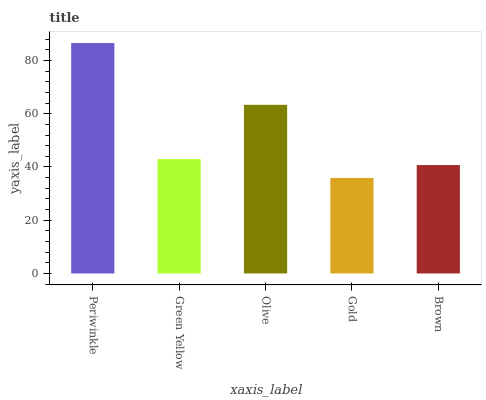Is Gold the minimum?
Answer yes or no. Yes. Is Periwinkle the maximum?
Answer yes or no. Yes. Is Green Yellow the minimum?
Answer yes or no. No. Is Green Yellow the maximum?
Answer yes or no. No. Is Periwinkle greater than Green Yellow?
Answer yes or no. Yes. Is Green Yellow less than Periwinkle?
Answer yes or no. Yes. Is Green Yellow greater than Periwinkle?
Answer yes or no. No. Is Periwinkle less than Green Yellow?
Answer yes or no. No. Is Green Yellow the high median?
Answer yes or no. Yes. Is Green Yellow the low median?
Answer yes or no. Yes. Is Gold the high median?
Answer yes or no. No. Is Periwinkle the low median?
Answer yes or no. No. 